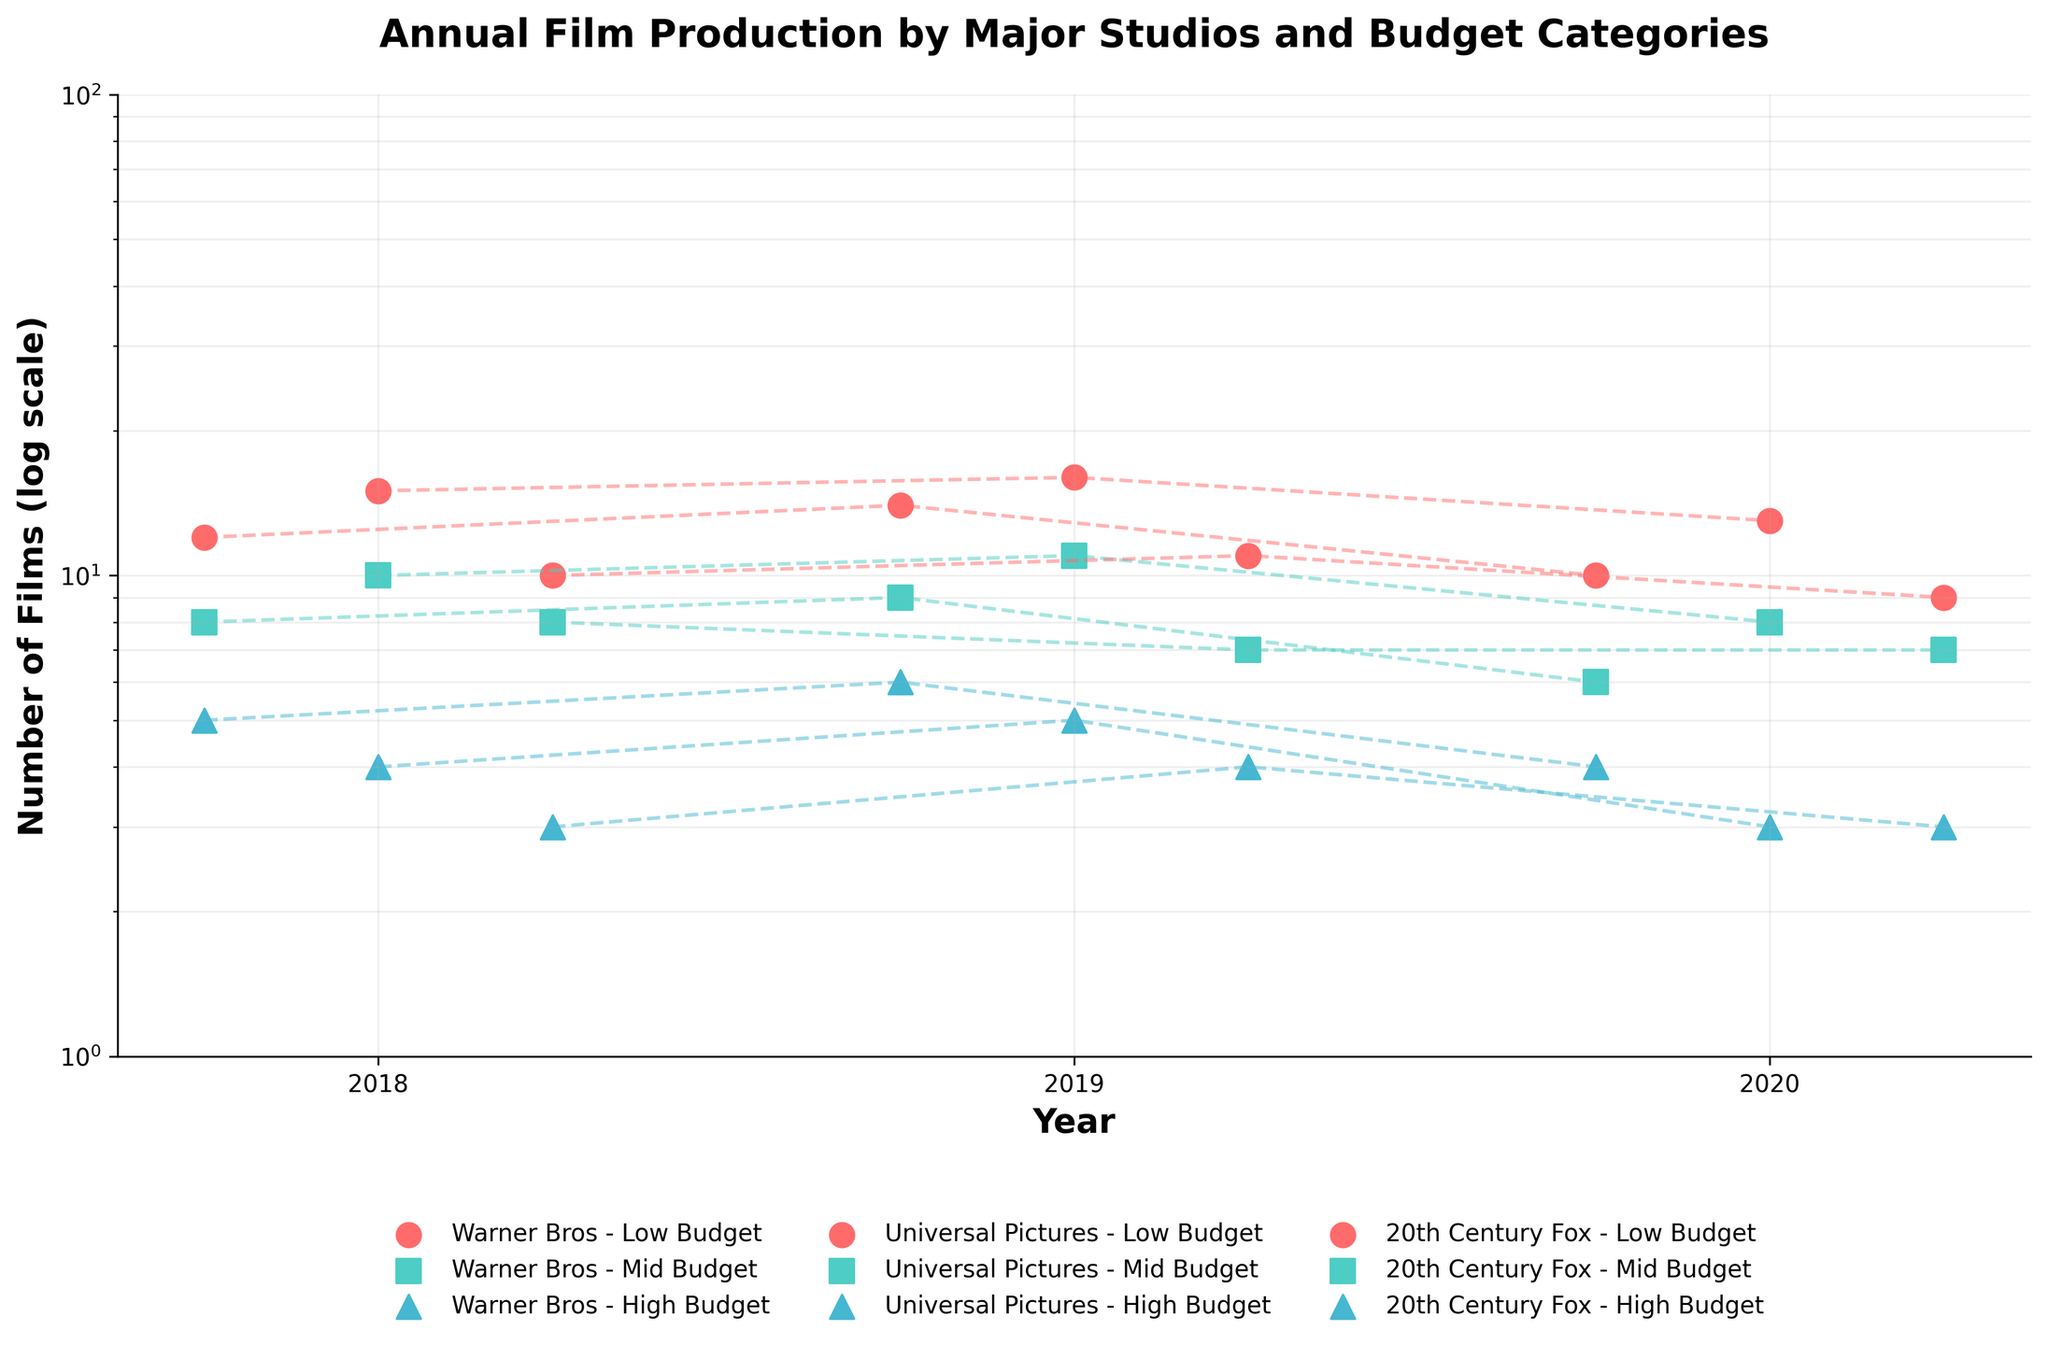What's the title of the figure? The title of the figure is prominently displayed at the top. It reads "Annual Film Production by Major Studios and Budget Categories".
Answer: Annual Film Production by Major Studios and Budget Categories What is the range set on the y-axis? The y-axis is on a log scale, ranging from 1 to 100. This can be determined by looking at the axis labels and noting the minimum and maximum values shown.
Answer: 1 to 100 Which studio produced the highest number of low budget films in 2018? In 2018, Universal Pictures produced the highest number of low budget films, as indicated by the highest point among the data points for low budget films for that year.
Answer: Universal Pictures Comparing Warner Bros and 20th Century Fox, which studio had a greater drop in the number of high budget films produced from 2019 to 2020? Warner Bros had 6 high budget films in 2019 and 4 in 2020, a drop of 2 films. 20th Century Fox had 4 high budget films in 2019 and 3 in 2020, a drop of 1 film. Thus, Warner Bros had a greater drop.
Answer: Warner Bros How many mid budget films were produced by Universal Pictures over the three years shown? Summing up the mid budget films produced by Universal Pictures across 2018, 2019, and 2020: 10 (2018) + 11 (2019) + 8 (2020) = 29 films.
Answer: 29 films Which studio has the most consistent production in high budget films over the years? All studios' high budget films fluctuate slightly, but 20th Century Fox is the most consistent with counts of 3 or 4 high budget films each year.
Answer: 20th Century Fox What trend do you notice about the number of low budget films produced by Warner Bros from 2018 to 2020? The number of low budget films produced by Warner Bros increases from 12 in 2018 to 14 in 2019, then decreases to 10 in 2020, showing an up-then-down trend.
Answer: Up-then-down Which budget category has the lowest overall production in each year across all studios? In each year, the high budget categories have the lowest number of films produced, as their data points are generally the lowest when compared to low and mid budget categories.
Answer: High budget What's the difference in the number of low budget films produced by Universal Pictures in 2018 and 2020? Universal Pictures produced 15 low budget films in 2018 and 13 in 2020, making the difference 15 - 13 = 2 films.
Answer: 2 films 